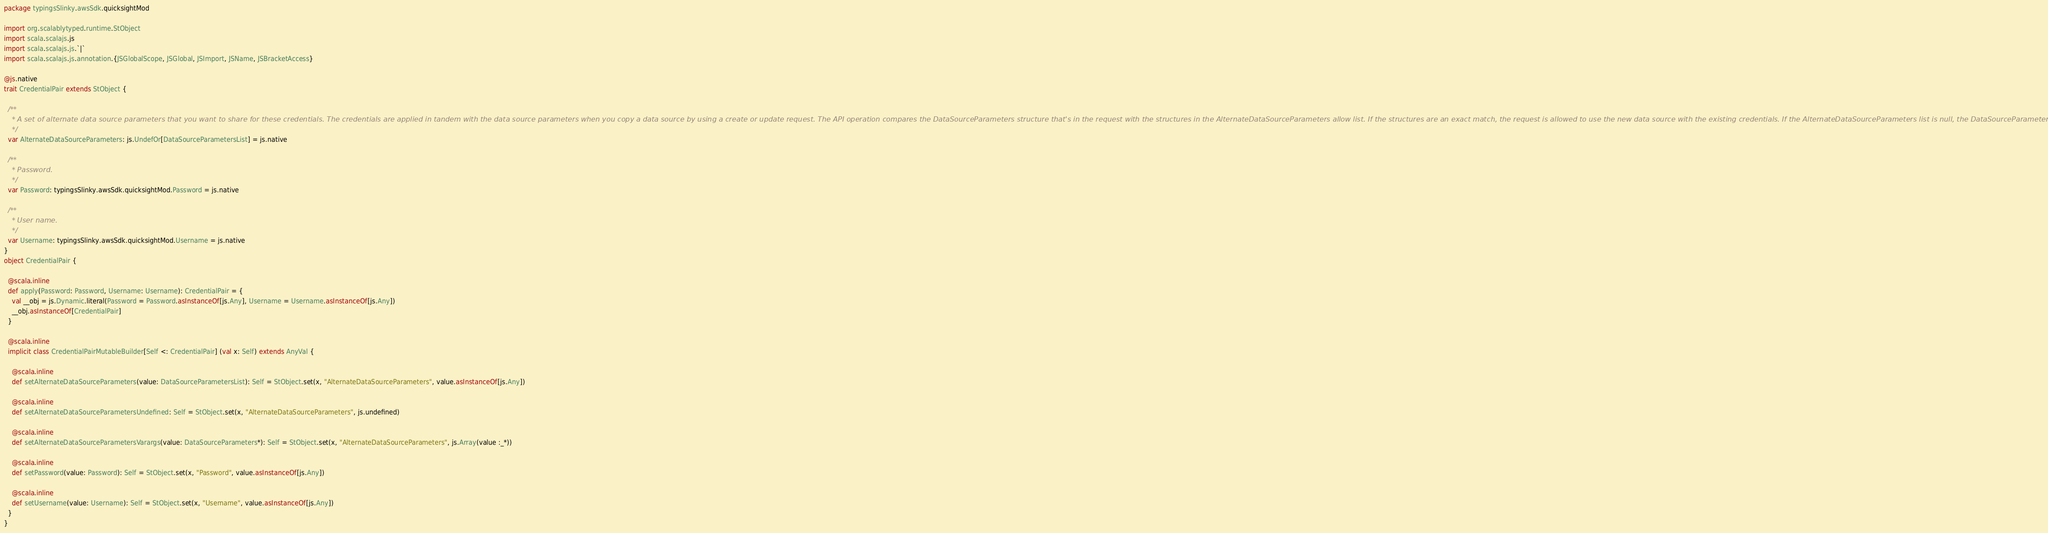<code> <loc_0><loc_0><loc_500><loc_500><_Scala_>package typingsSlinky.awsSdk.quicksightMod

import org.scalablytyped.runtime.StObject
import scala.scalajs.js
import scala.scalajs.js.`|`
import scala.scalajs.js.annotation.{JSGlobalScope, JSGlobal, JSImport, JSName, JSBracketAccess}

@js.native
trait CredentialPair extends StObject {
  
  /**
    * A set of alternate data source parameters that you want to share for these credentials. The credentials are applied in tandem with the data source parameters when you copy a data source by using a create or update request. The API operation compares the DataSourceParameters structure that's in the request with the structures in the AlternateDataSourceParameters allow list. If the structures are an exact match, the request is allowed to use the new data source with the existing credentials. If the AlternateDataSourceParameters list is null, the DataSourceParameters originally used with these Credentials is automatically allowed.
    */
  var AlternateDataSourceParameters: js.UndefOr[DataSourceParametersList] = js.native
  
  /**
    * Password.
    */
  var Password: typingsSlinky.awsSdk.quicksightMod.Password = js.native
  
  /**
    * User name.
    */
  var Username: typingsSlinky.awsSdk.quicksightMod.Username = js.native
}
object CredentialPair {
  
  @scala.inline
  def apply(Password: Password, Username: Username): CredentialPair = {
    val __obj = js.Dynamic.literal(Password = Password.asInstanceOf[js.Any], Username = Username.asInstanceOf[js.Any])
    __obj.asInstanceOf[CredentialPair]
  }
  
  @scala.inline
  implicit class CredentialPairMutableBuilder[Self <: CredentialPair] (val x: Self) extends AnyVal {
    
    @scala.inline
    def setAlternateDataSourceParameters(value: DataSourceParametersList): Self = StObject.set(x, "AlternateDataSourceParameters", value.asInstanceOf[js.Any])
    
    @scala.inline
    def setAlternateDataSourceParametersUndefined: Self = StObject.set(x, "AlternateDataSourceParameters", js.undefined)
    
    @scala.inline
    def setAlternateDataSourceParametersVarargs(value: DataSourceParameters*): Self = StObject.set(x, "AlternateDataSourceParameters", js.Array(value :_*))
    
    @scala.inline
    def setPassword(value: Password): Self = StObject.set(x, "Password", value.asInstanceOf[js.Any])
    
    @scala.inline
    def setUsername(value: Username): Self = StObject.set(x, "Username", value.asInstanceOf[js.Any])
  }
}
</code> 